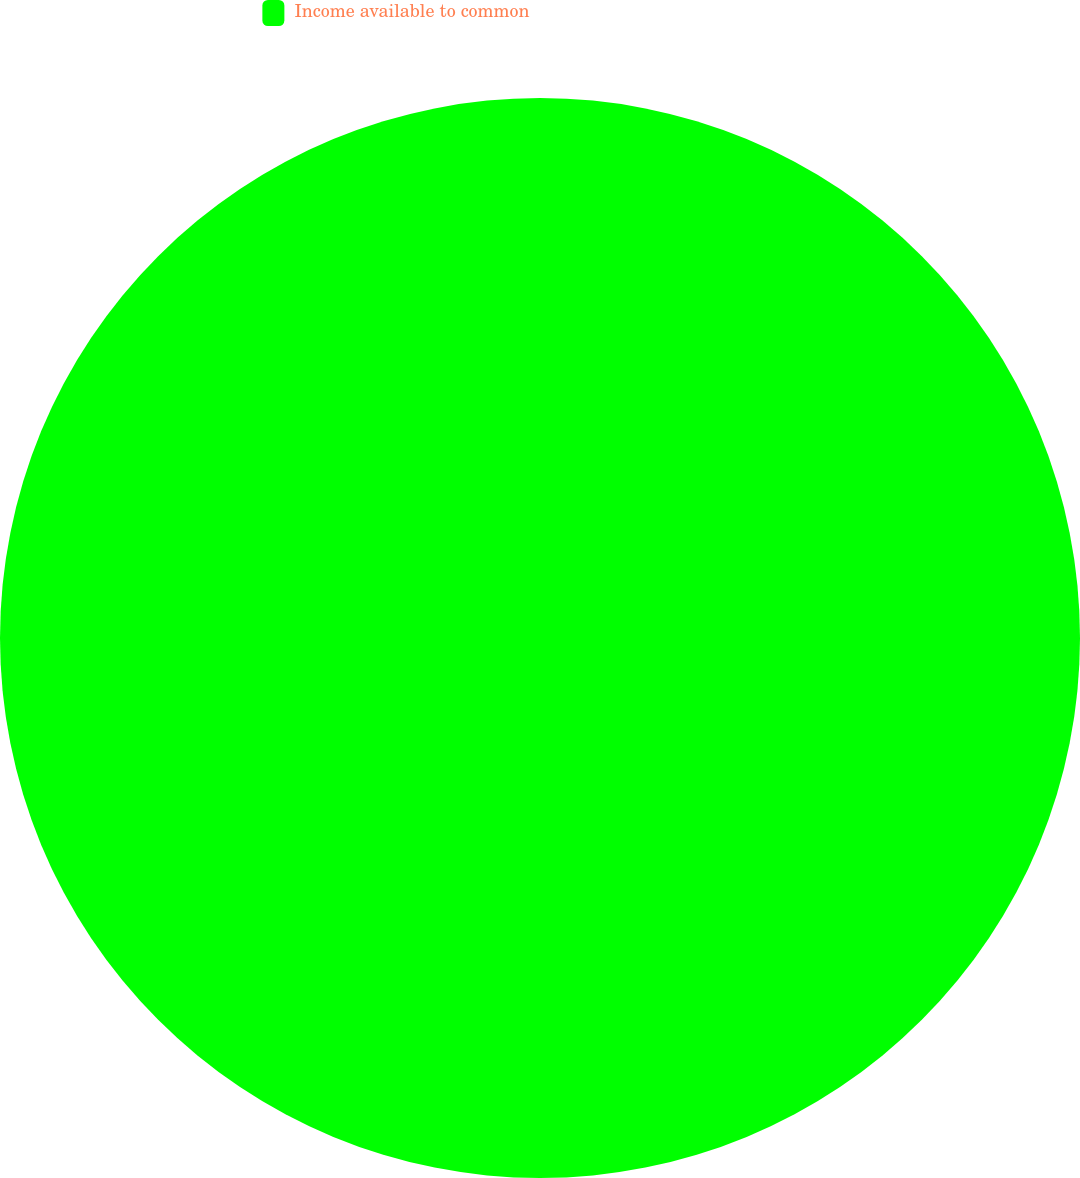Convert chart to OTSL. <chart><loc_0><loc_0><loc_500><loc_500><pie_chart><fcel>Income available to common<nl><fcel>100.0%<nl></chart> 